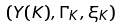Convert formula to latex. <formula><loc_0><loc_0><loc_500><loc_500>( Y ( K ) , \Gamma _ { K } , \xi _ { K } )</formula> 